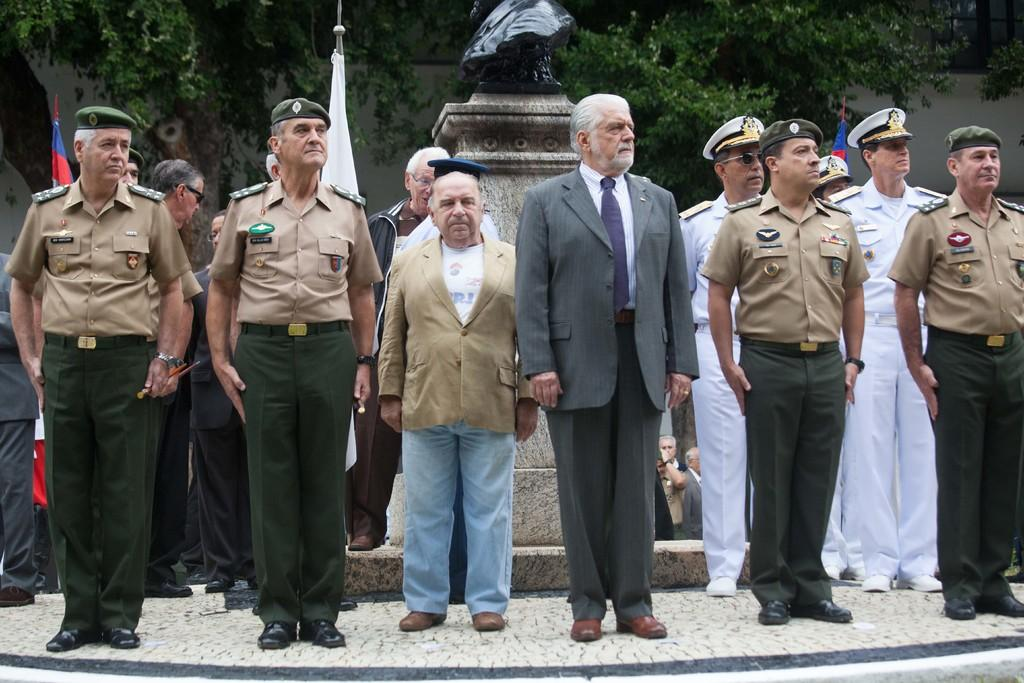What is the main subject in the middle of the image? There is a man standing in the middle of the image. What is the man wearing in the image? The man is wearing a coat, tie, shirt, trousers, and shoes. Are there any other people in the image? Yes, there are other men standing beside him. What are the other men wearing in the image? The other men are wearing caps. What can be seen in the background of the image? Trees are visible behind the men. What time does the man's watch show in the image? There is no watch visible in the image, so it is not possible to determine the time. 